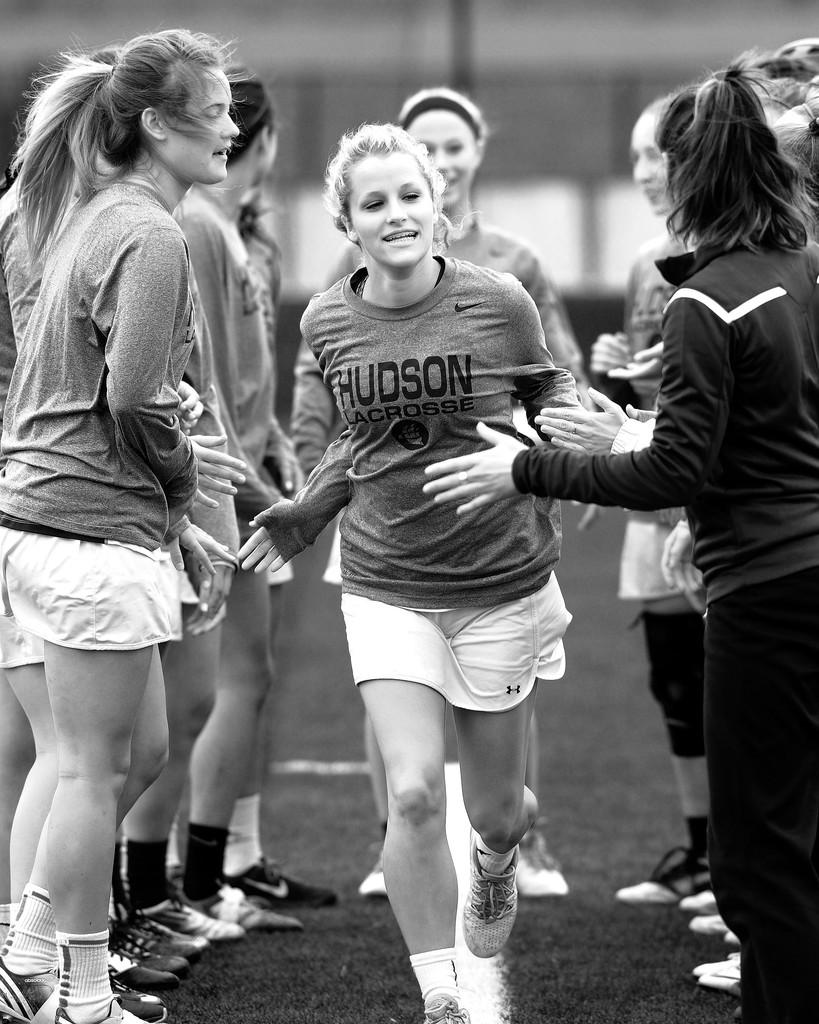What is the color scheme of the image? The image is black and white. Who or what is located in the center of the image? There are girls in the center of the image. What type of terrain is visible at the bottom of the image? There is grass at the bottom of the image. Can you tell me how many geese are in the image? There are no geese present in the image. Is there a writer visible in the image? There is no writer present in the image. 